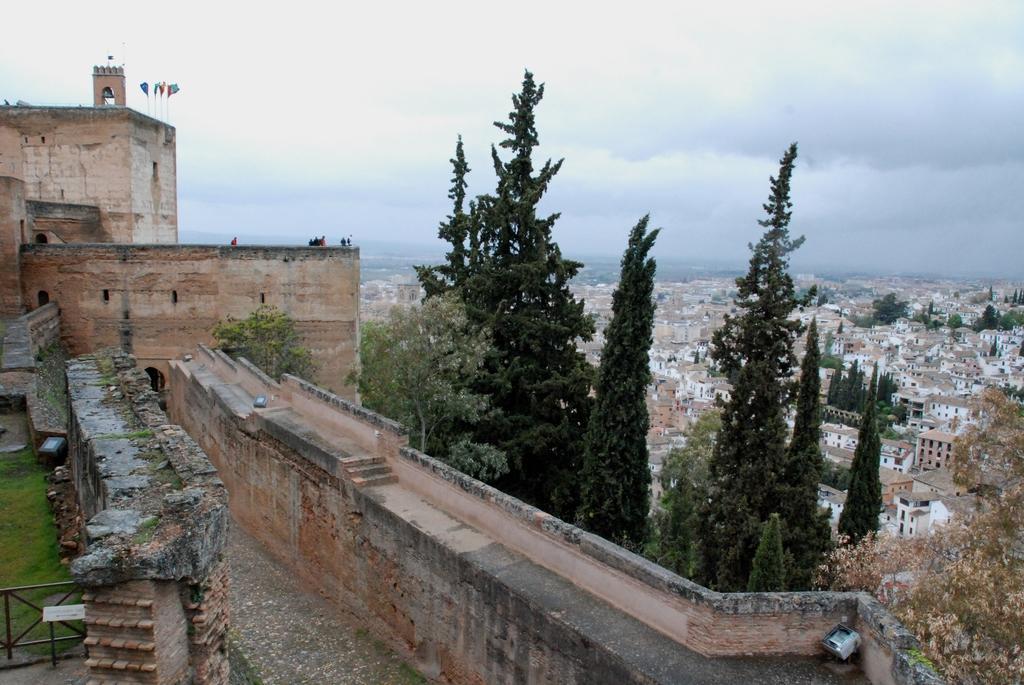Can you describe this image briefly? In the image there is a castle on the left side with trees in front of it, on the right side it seems to be a city with many buildings all over it and above its sky with clouds. 